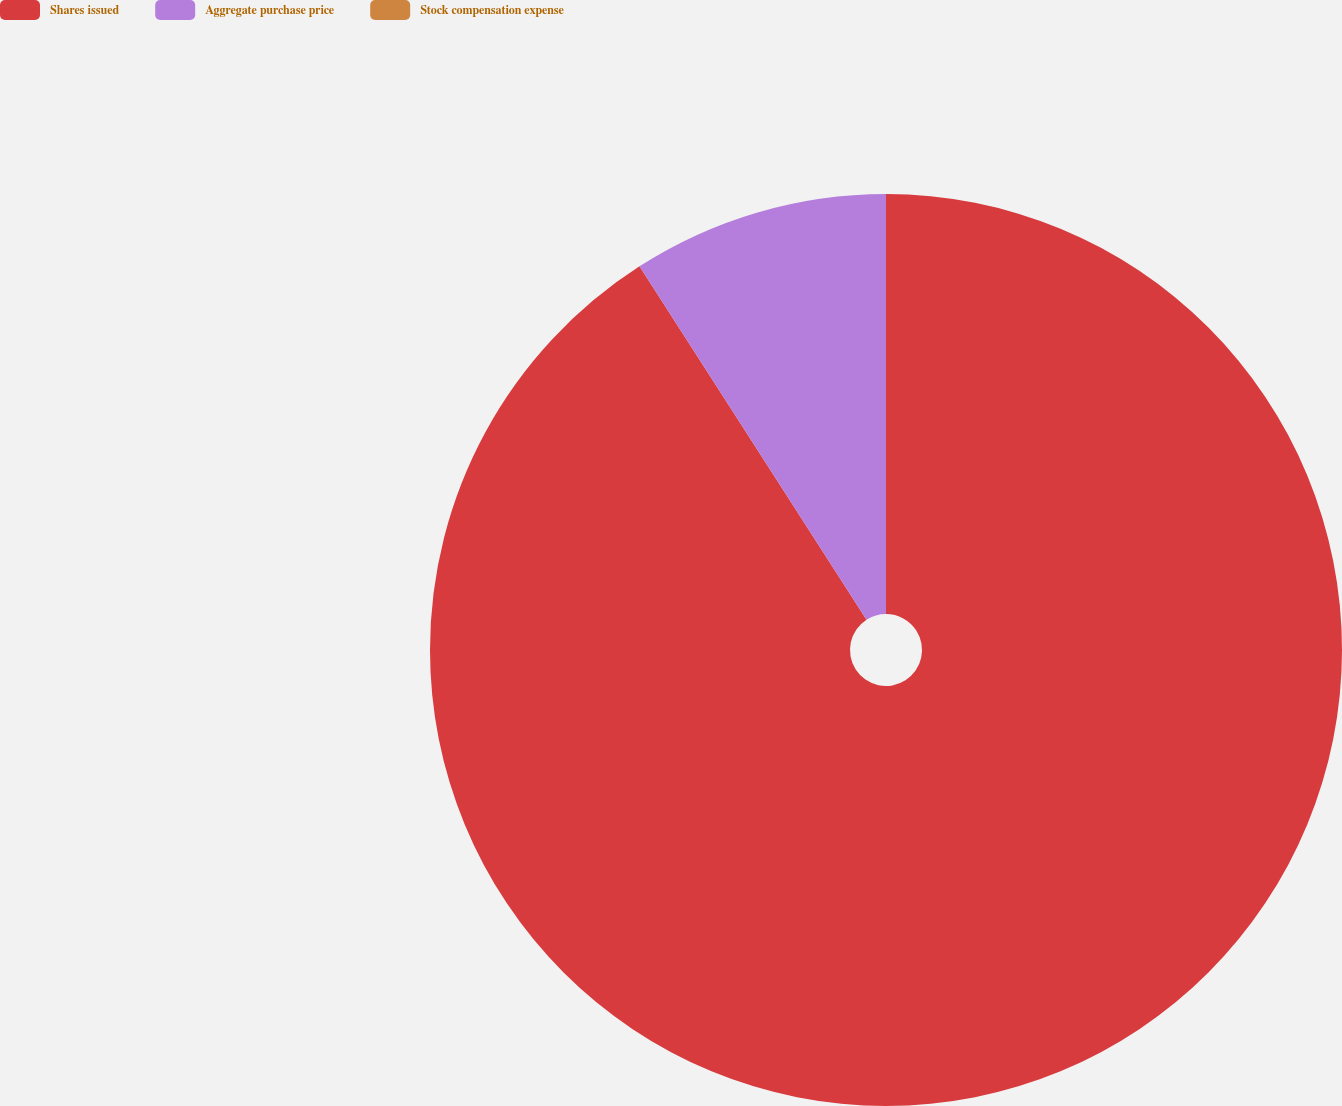Convert chart to OTSL. <chart><loc_0><loc_0><loc_500><loc_500><pie_chart><fcel>Shares issued<fcel>Aggregate purchase price<fcel>Stock compensation expense<nl><fcel>90.91%<fcel>9.09%<fcel>0.0%<nl></chart> 